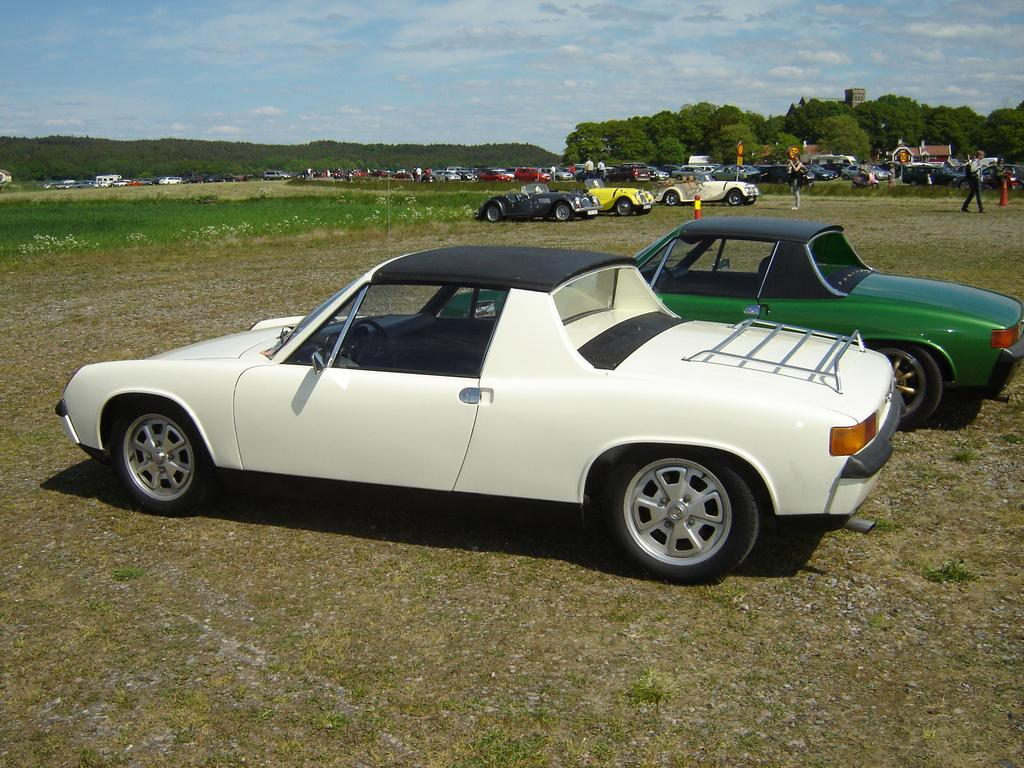What is the main subject of the image? The main subject of the image is many cars. What can be seen on the ground in the image? There is grass on the ground in the image. What is visible in the background of the image? There are trees and the sky in the background of the image. What is present in the sky? Clouds are present in the sky. Where is the hole in the image, and what is it used for? There is no hole present in the image. What type of grain can be seen growing in the image? There is no grain visible in the image. 